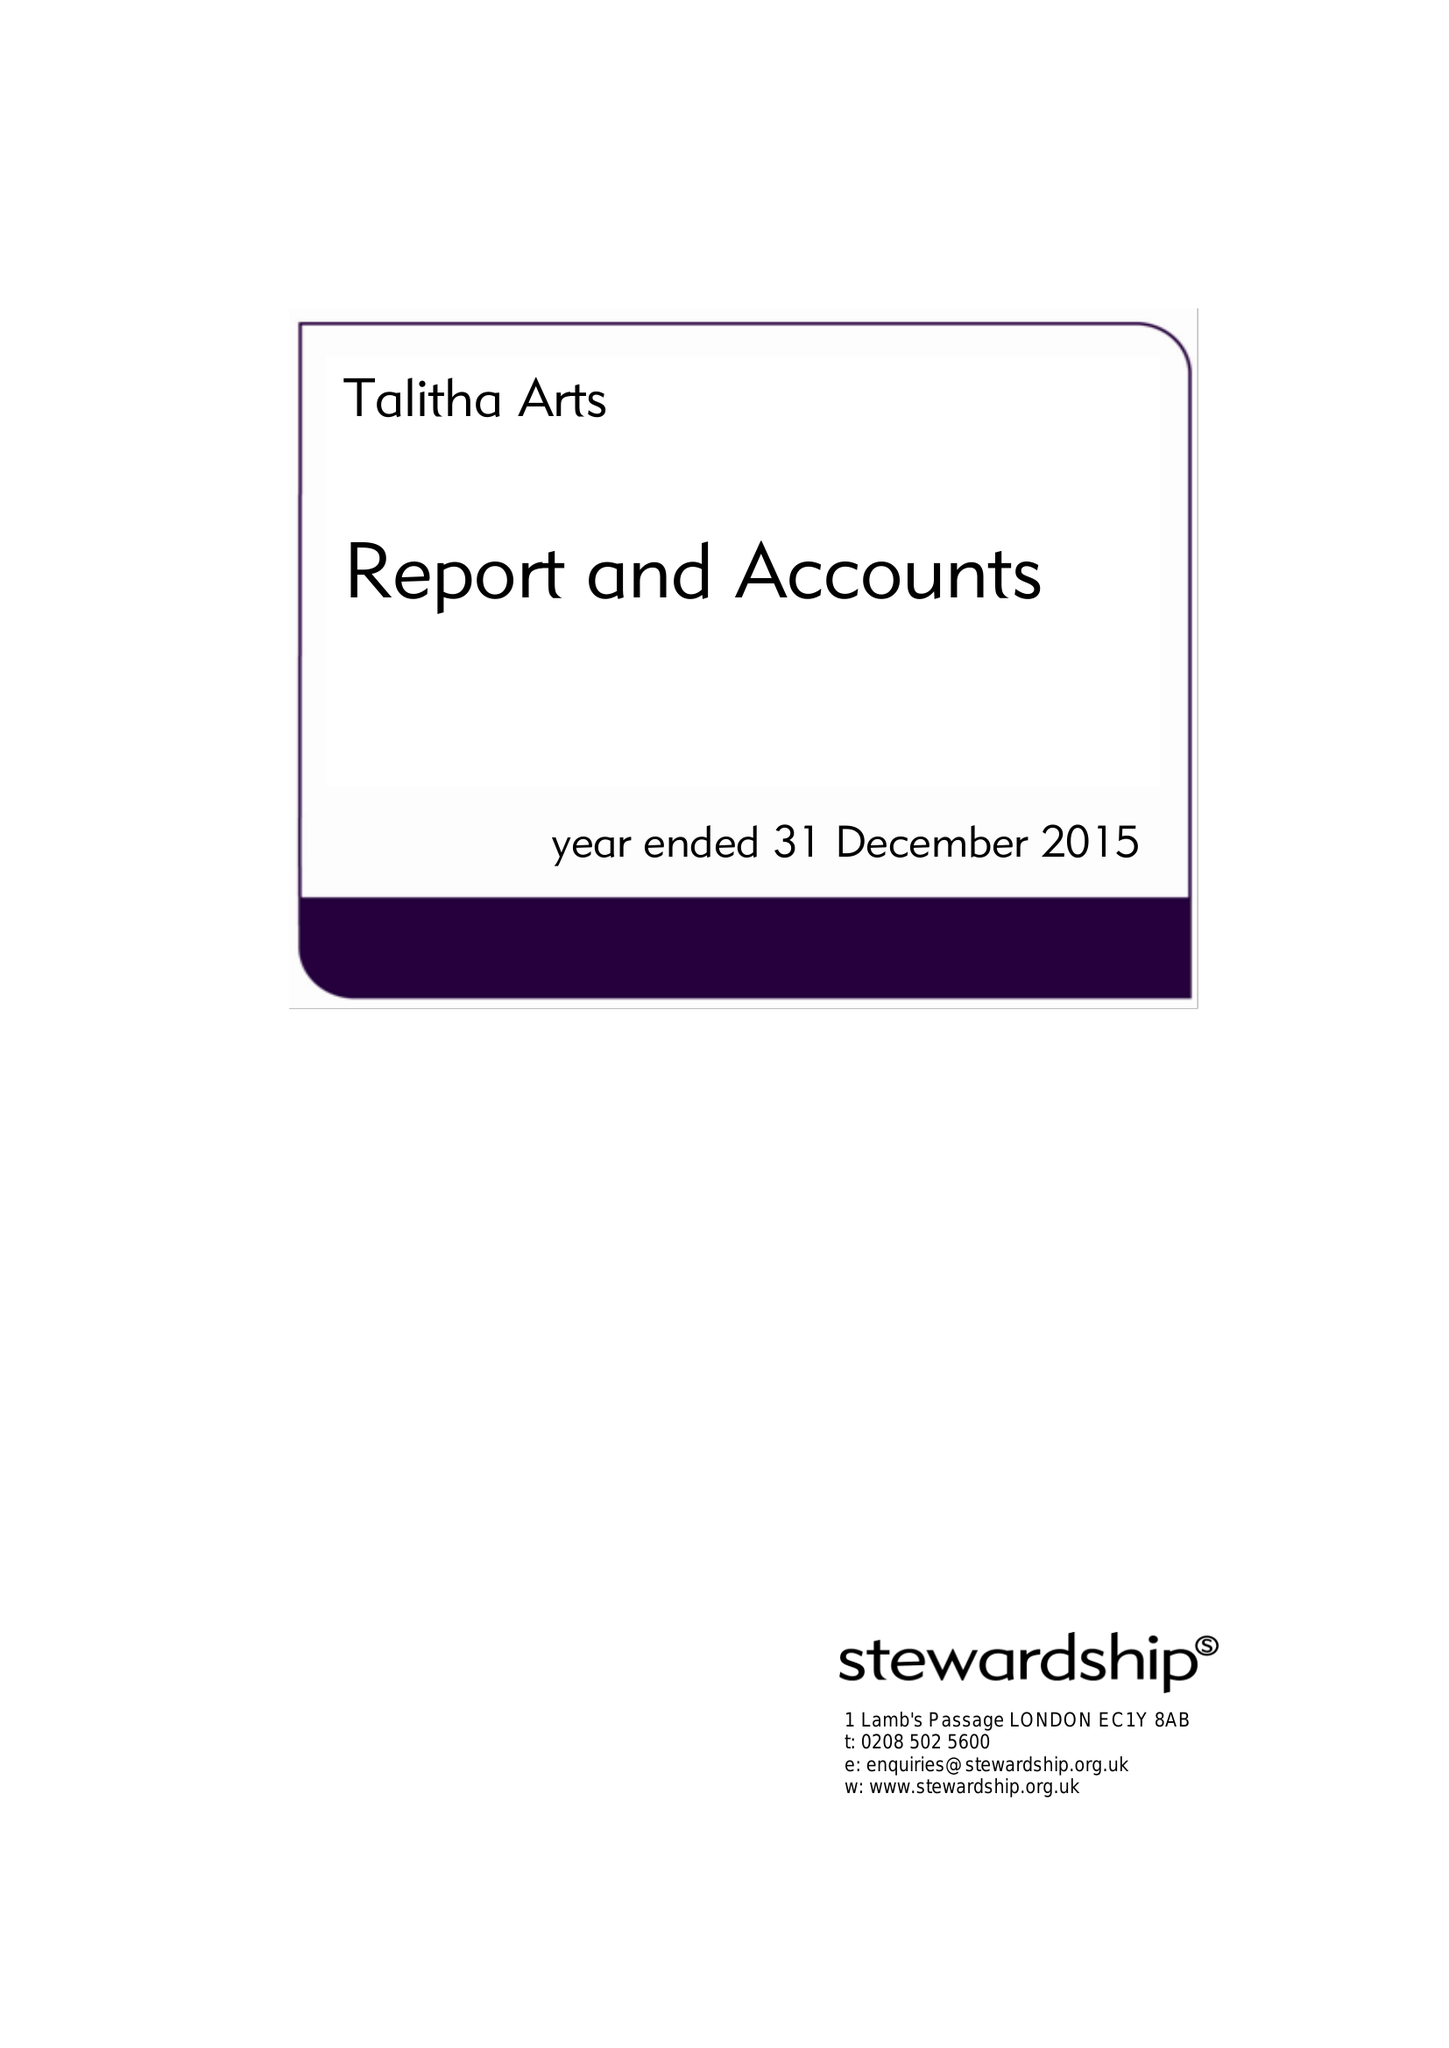What is the value for the charity_name?
Answer the question using a single word or phrase. Talitha Arts 